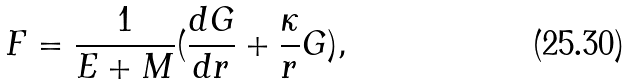<formula> <loc_0><loc_0><loc_500><loc_500>F = \frac { 1 } { E + M } ( \frac { d G } { d r } + \frac { \kappa } { r } G ) ,</formula> 